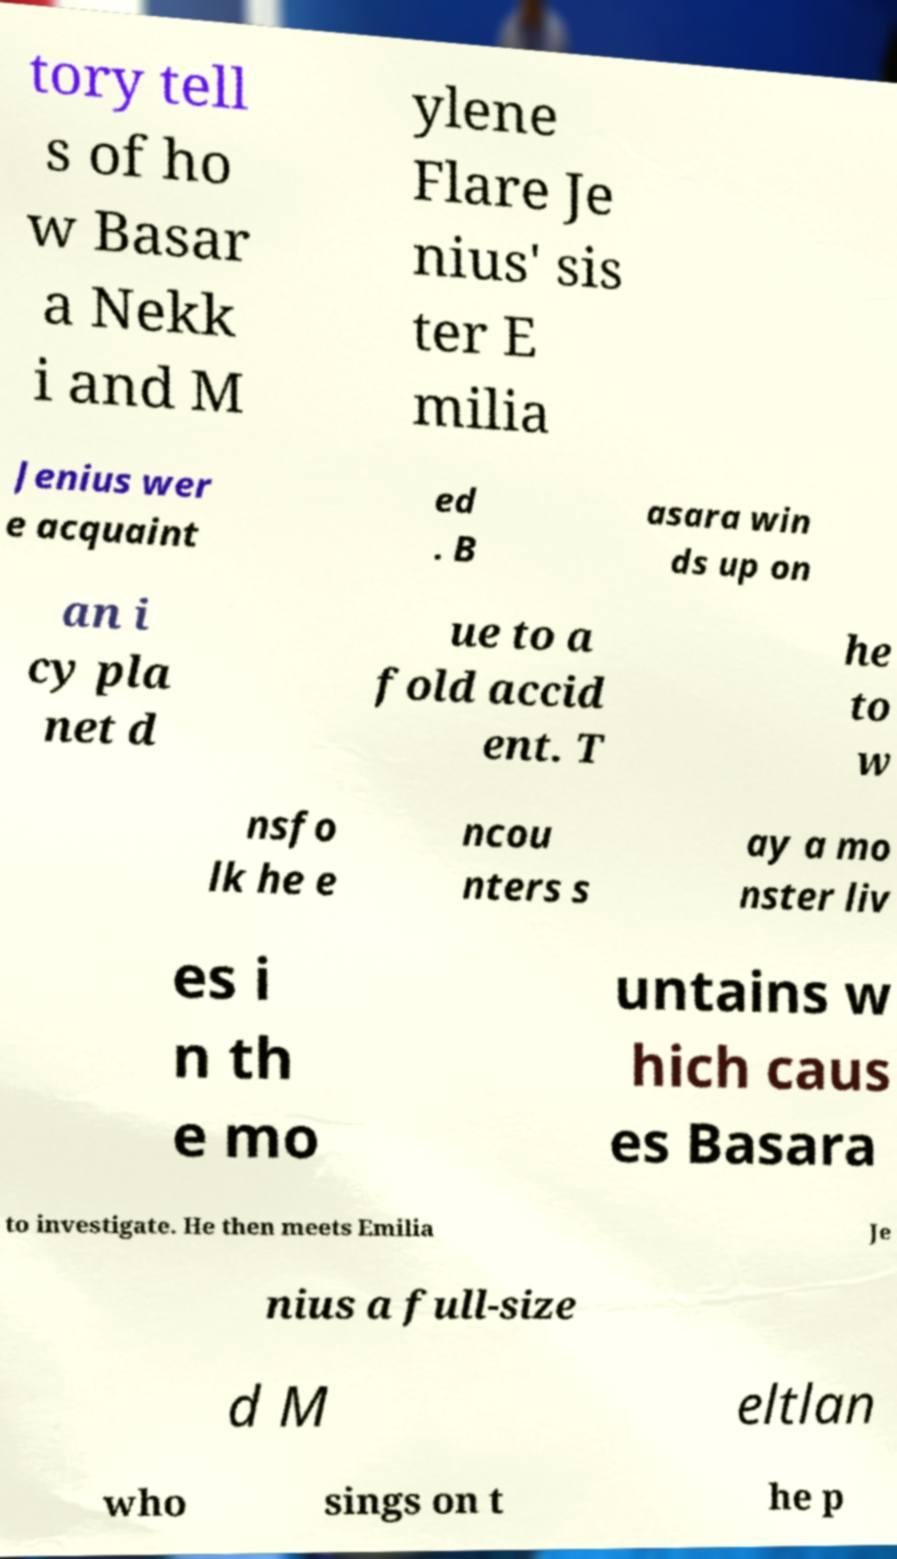Can you accurately transcribe the text from the provided image for me? tory tell s of ho w Basar a Nekk i and M ylene Flare Je nius' sis ter E milia Jenius wer e acquaint ed . B asara win ds up on an i cy pla net d ue to a fold accid ent. T he to w nsfo lk he e ncou nters s ay a mo nster liv es i n th e mo untains w hich caus es Basara to investigate. He then meets Emilia Je nius a full-size d M eltlan who sings on t he p 